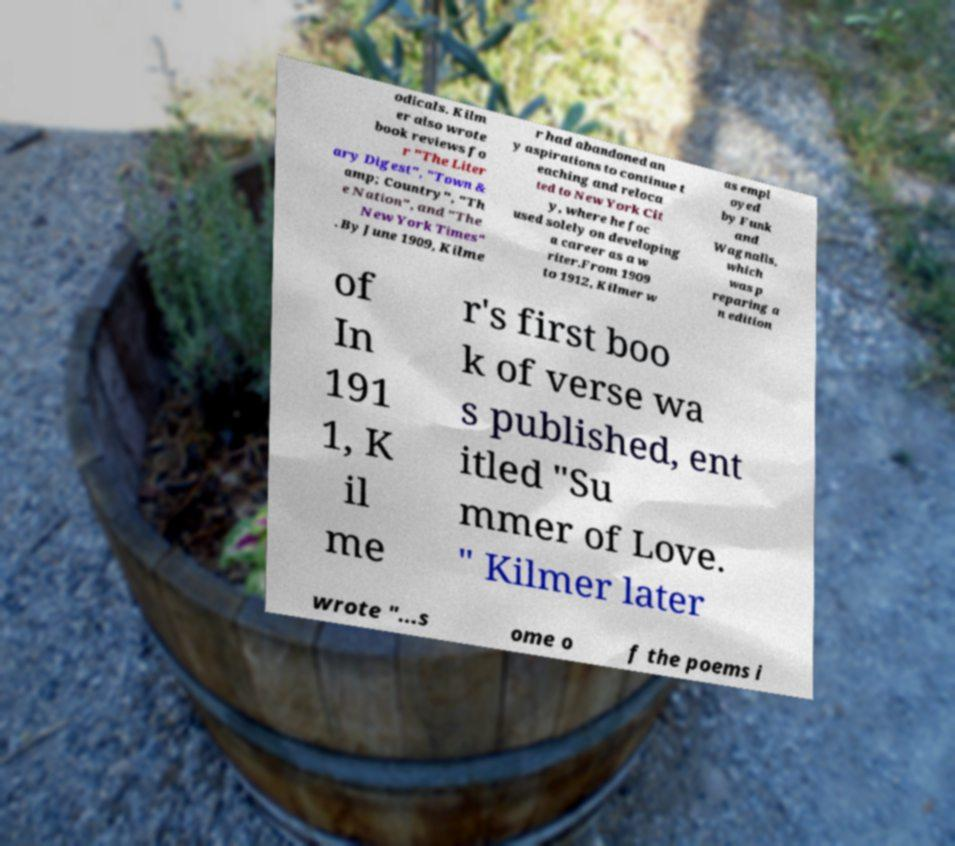Could you extract and type out the text from this image? odicals. Kilm er also wrote book reviews fo r "The Liter ary Digest", "Town & amp; Country", "Th e Nation", and "The New York Times" . By June 1909, Kilme r had abandoned an y aspirations to continue t eaching and reloca ted to New York Cit y, where he foc used solely on developing a career as a w riter.From 1909 to 1912, Kilmer w as empl oyed by Funk and Wagnalls, which was p reparing a n edition of In 191 1, K il me r's first boo k of verse wa s published, ent itled "Su mmer of Love. " Kilmer later wrote "...s ome o f the poems i 